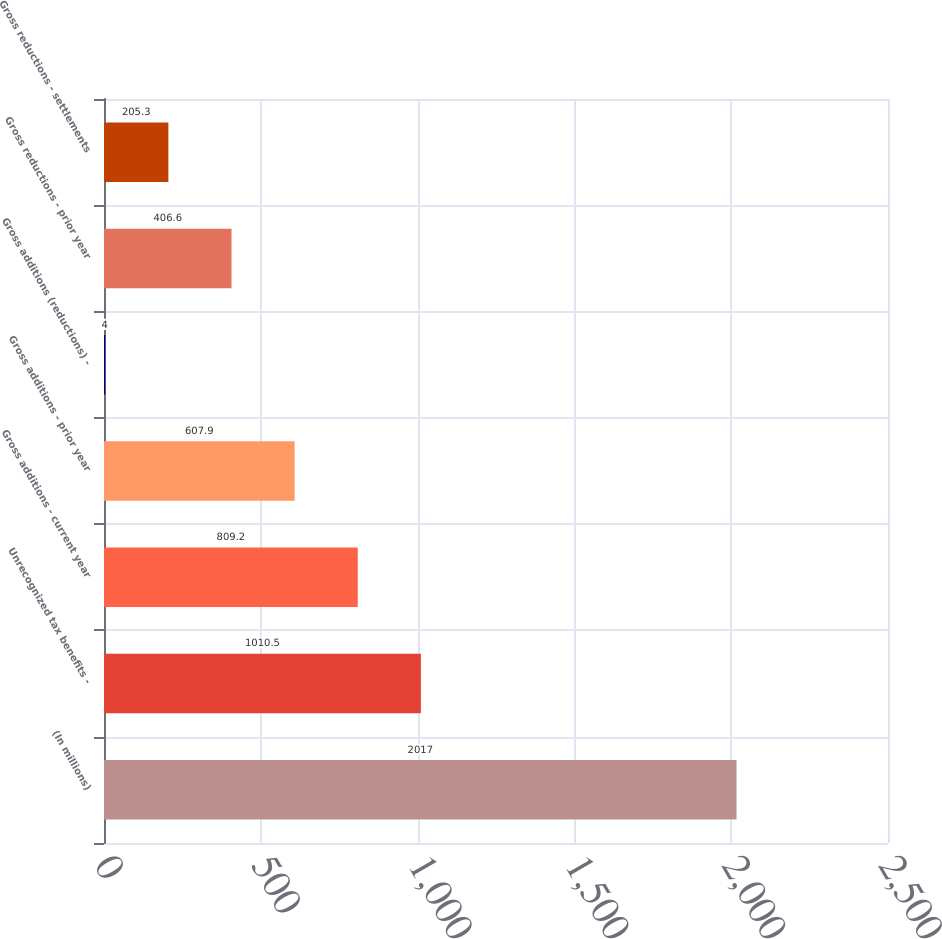<chart> <loc_0><loc_0><loc_500><loc_500><bar_chart><fcel>(In millions)<fcel>Unrecognized tax benefits -<fcel>Gross additions - current year<fcel>Gross additions - prior year<fcel>Gross additions (reductions) -<fcel>Gross reductions - prior year<fcel>Gross reductions - settlements<nl><fcel>2017<fcel>1010.5<fcel>809.2<fcel>607.9<fcel>4<fcel>406.6<fcel>205.3<nl></chart> 